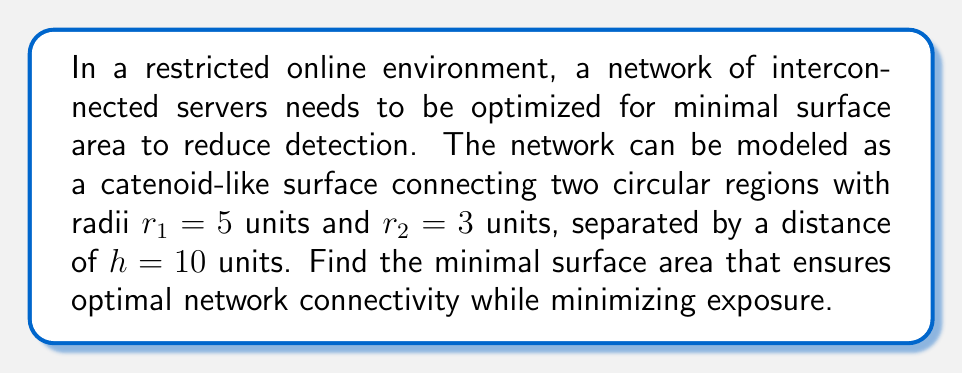Can you answer this question? To solve this problem, we'll use the principles of differential geometry and minimal surfaces:

1) The surface of revolution that minimizes the area between two circular regions is a catenoid.

2) The parameterization of a catenoid is given by:
   $$x(u,v) = a \cosh(\frac{v}{a}) \cos(u)$$
   $$y(u,v) = a \cosh(\frac{v}{a}) \sin(u)$$
   $$z(v) = v$$
   where $a$ is the scaling factor.

3) To find $a$, we need to solve:
   $$r_1 = a \cosh(\frac{h}{2a})$$
   $$r_2 = a \cosh(-\frac{h}{2a})$$

4) Since $\cosh$ is an even function, we can simplify to:
   $$\frac{r_1 + r_2}{2} = a \cosh(\frac{h}{2a})$$

5) Substituting our values:
   $$4 = a \cosh(\frac{5}{a})$$

6) This transcendental equation can be solved numerically, giving $a \approx 2.3858$.

7) The surface area of a catenoid is given by:
   $$A = 2\pi a^2 [\sinh(\frac{h}{2a}) \cosh(\frac{h}{2a}) - \frac{h}{2a}]$$

8) Substituting our values:
   $$A = 2\pi (2.3858)^2 [\sinh(\frac{5}{2.3858}) \cosh(\frac{5}{2.3858}) - \frac{5}{2.3858}]$$

9) Calculating this gives us the minimal surface area.

[asy]
import graph3;
size(200);
currentprojection=perspective(6,3,2);
real a = 2.3858;
real f(real x) {return a*cosh(x/a);}
revolution r=revolution(graph(f,-5,5,operator ..),axis=Z);
draw(r,material(paleblue+opacity(.5)));
draw(circle((0,0,-5),5));
draw(circle((0,0,5),3));
[/asy]
Answer: $A \approx 185.4$ square units 